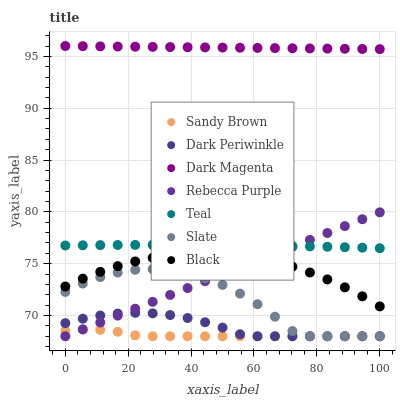Does Sandy Brown have the minimum area under the curve?
Answer yes or no. Yes. Does Dark Magenta have the maximum area under the curve?
Answer yes or no. Yes. Does Slate have the minimum area under the curve?
Answer yes or no. No. Does Slate have the maximum area under the curve?
Answer yes or no. No. Is Dark Magenta the smoothest?
Answer yes or no. Yes. Is Slate the roughest?
Answer yes or no. Yes. Is Black the smoothest?
Answer yes or no. No. Is Black the roughest?
Answer yes or no. No. Does Slate have the lowest value?
Answer yes or no. Yes. Does Black have the lowest value?
Answer yes or no. No. Does Dark Magenta have the highest value?
Answer yes or no. Yes. Does Slate have the highest value?
Answer yes or no. No. Is Slate less than Teal?
Answer yes or no. Yes. Is Dark Magenta greater than Black?
Answer yes or no. Yes. Does Dark Periwinkle intersect Sandy Brown?
Answer yes or no. Yes. Is Dark Periwinkle less than Sandy Brown?
Answer yes or no. No. Is Dark Periwinkle greater than Sandy Brown?
Answer yes or no. No. Does Slate intersect Teal?
Answer yes or no. No. 